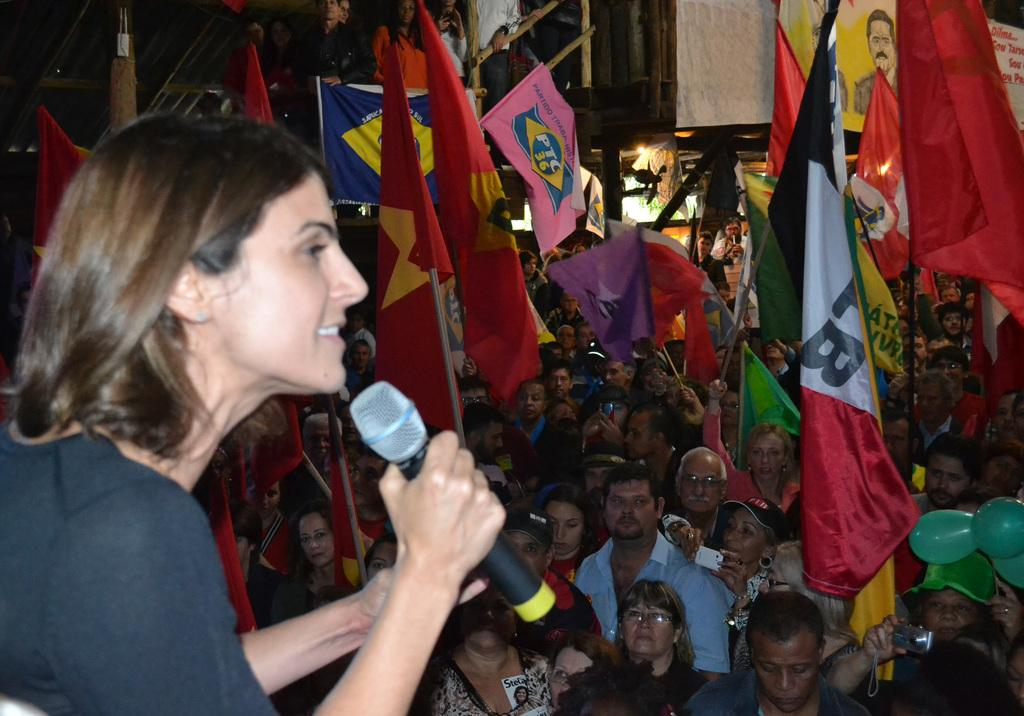What are the people in the image doing? The people in the image are standing and holding flags in their hands. Can you describe the woman in the image? There is a woman holding a microphone to the left. What is visible at the top of the image? There is a railing at the top of the image. What type of soap is being used to clean the flags in the image? There is no soap or cleaning activity depicted in the image; the people are simply holding flags. 